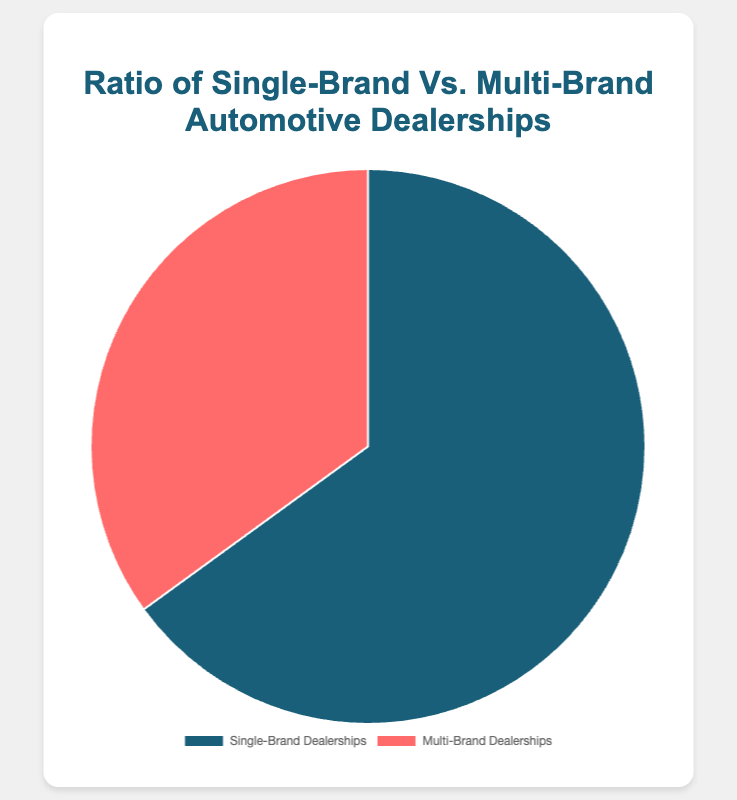what percentage of automotive dealerships are single-brand? From the pie chart, the segment marked for single-brand dealerships shows 65%.
Answer: 65% what percentage of automotive dealerships are multi-brand? The pie chart indicates that the segment for multi-brand dealerships represents 35%.
Answer: 35% which type of dealership is more common? Comparing the two segments, single-brand dealerships occupy 65%, whereas multi-brand dealerships are at 35%. Hence, single-brand dealerships are more common.
Answer: Single-brand dealerships how many more percentage points are there for single-brand dealerships compared to multi-brand dealerships? The percentage for single-brand dealerships is 65%, and for multi-brand dealerships, it's 35%. So, the difference is 65% - 35% = 30%.
Answer: 30% what fraction of automotive dealerships are multi-brand? The multi-brand dealerships make up 35% of the total. Therefore, the fraction is 35/100 = 7/20.
Answer: 7/20 how does the color representing single-brand dealerships compare to the color representing multi-brand dealerships? Visually, single-brand dealerships are represented by a shade of blue, whereas multi-brand dealerships are represented by a shade of red.
Answer: Blue vs. Red what portion of the circle does multi-brand dealerships occupy, compared to single-brand dealerships? Multi-brand dealerships take up 35% of the pie chart, and single-brand dealerships take up 65%. To compare, the multi-brand slice is just over half the size of the single-brand slice.
Answer: Just over half if the total number of dealerships is 200, how many are single-brand? Given that 65% of the dealerships are single-brand, we calculate 65% of 200, which is (65/100) * 200 = 130.
Answer: 130 if the total number of dealerships increases, how would this chart visually change, assuming the ratio remains the same? Assuming the ratio remains the same, the relative size and color proportions of the segments would remain unchanged. Only the total count represented by each segment would increase.
Answer: No visual change in proportions 